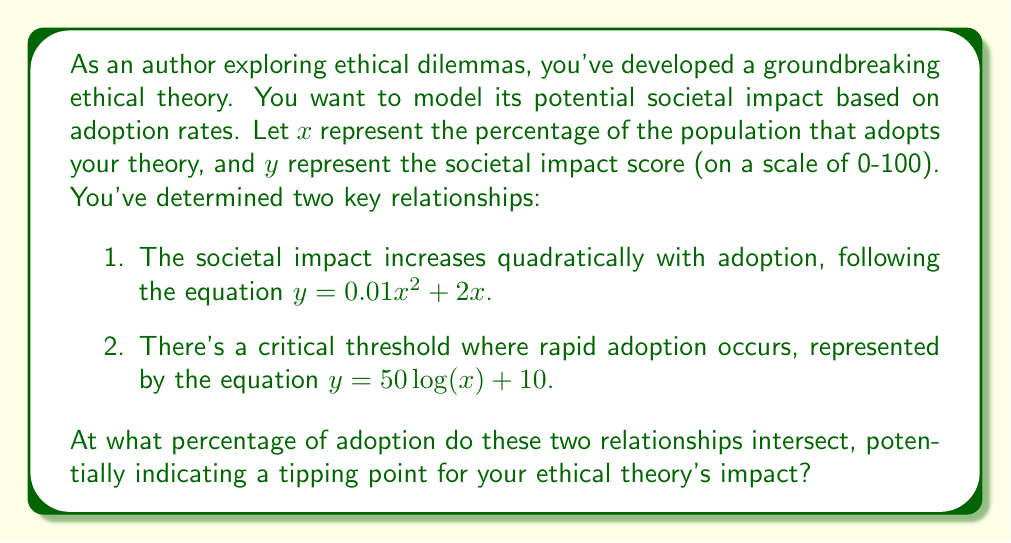Give your solution to this math problem. To solve this problem, we need to find the point of intersection between the two equations representing the societal impact. Let's approach this step-by-step:

1. We have two equations:
   Equation 1: $y = 0.01x^2 + 2x$
   Equation 2: $y = 50 \log(x) + 10$

2. At the point of intersection, both equations will be equal. So we can set them equal to each other:

   $0.01x^2 + 2x = 50 \log(x) + 10$

3. This equation cannot be solved algebraically due to the presence of both $x^2$ and $\log(x)$ terms. We need to use numerical methods or graphing to find the solution.

4. Using a graphing calculator or computer software, we can plot both equations and find their intersection point.

5. The graphs intersect at approximately $x = 20.6$ and $y = 51.2$.

6. To verify, we can plug this x-value into both equations:

   Equation 1: $y = 0.01(20.6)^2 + 2(20.6) = 4.24 + 41.2 = 45.44$
   Equation 2: $y = 50 \log(20.6) + 10 = 50(1.31) + 10 = 65.5 + 10 = 75.5$

7. The exact intersection point lies between these two values, closer to 20.6% adoption.

Therefore, the tipping point for your ethical theory's impact occurs when approximately 20.6% of the population adopts it.
Answer: The ethical theory reaches its tipping point at approximately 20.6% adoption. 